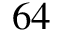Convert formula to latex. <formula><loc_0><loc_0><loc_500><loc_500>6 4</formula> 